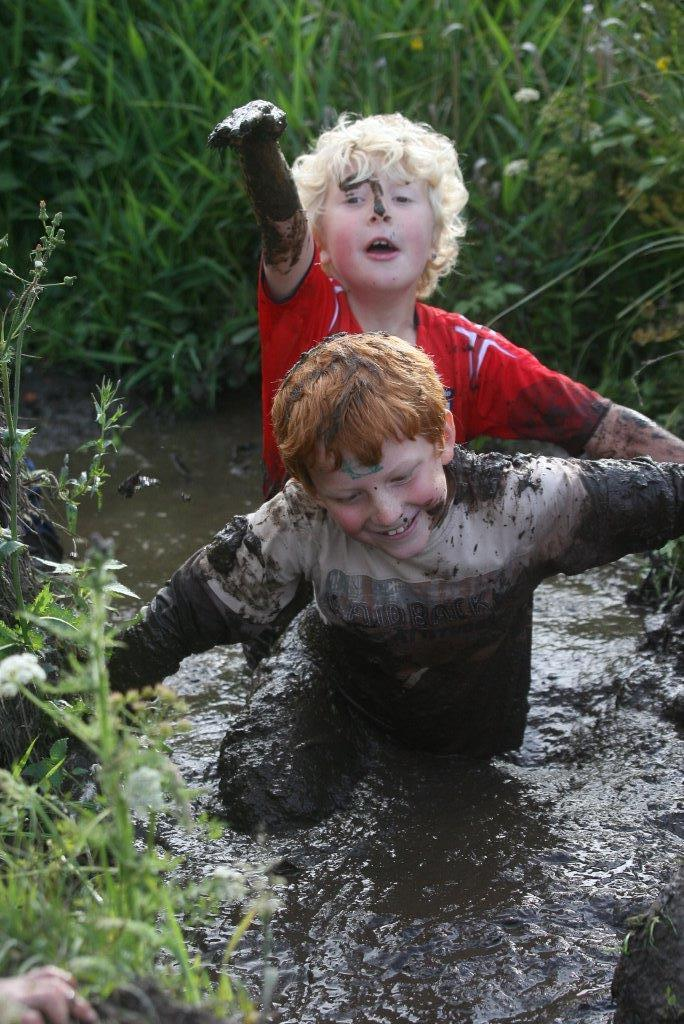How many kids are in the image? There are two kids in the image. What are the kids doing in the image? The kids are standing in mud water. What else can be seen in the image besides the kids? There are plants and trees in the image. What color is the leg of the table in the image? There is no table present in the image, so it is not possible to determine the color of its leg. 